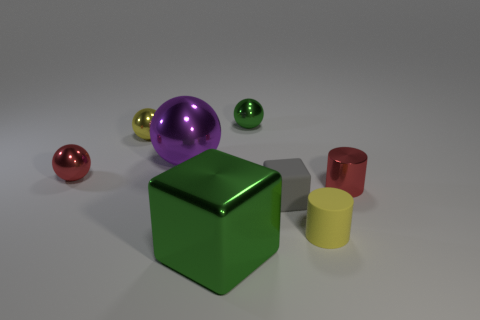Subtract all red balls. How many balls are left? 3 Add 2 large green shiny blocks. How many objects exist? 10 Subtract all green cubes. How many cubes are left? 1 Subtract all cylinders. How many objects are left? 6 Subtract 1 spheres. How many spheres are left? 3 Add 2 small shiny balls. How many small shiny balls are left? 5 Add 8 big purple shiny spheres. How many big purple shiny spheres exist? 9 Subtract 1 yellow cylinders. How many objects are left? 7 Subtract all red spheres. Subtract all red blocks. How many spheres are left? 3 Subtract all blue cylinders. How many green cubes are left? 1 